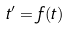Convert formula to latex. <formula><loc_0><loc_0><loc_500><loc_500>t ^ { \prime } = f ( t )</formula> 